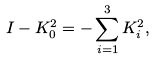<formula> <loc_0><loc_0><loc_500><loc_500>I - K _ { 0 } ^ { 2 } = - \sum _ { i = 1 } ^ { 3 } { K _ { i } ^ { 2 } } ,</formula> 